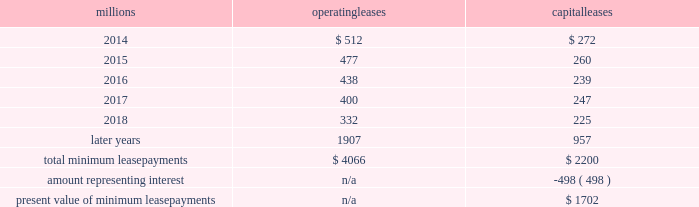On december 19 , 2011 , we redeemed the remaining $ 175 million of our 6.5% ( 6.5 % ) notes due april 15 , 2012 , and all $ 300 million of our outstanding 6.125% ( 6.125 % ) notes due january 15 , 2012 .
The redemptions resulted in an early extinguishment charge of $ 5 million in the fourth quarter of 2011 .
Receivables securitization facility 2013 as of december 31 , 2013 and 2012 , we recorded $ 0 and $ 100 million , respectively , as secured debt under our receivables securitization facility .
( see further discussion of our receivables securitization facility in note 10 ) .
15 .
Variable interest entities we have entered into various lease transactions in which the structure of the leases contain variable interest entities ( vies ) .
These vies were created solely for the purpose of doing lease transactions ( principally involving railroad equipment and facilities , including our headquarters building ) and have no other activities , assets or liabilities outside of the lease transactions .
Within these lease arrangements , we have the right to purchase some or all of the assets at fixed prices .
Depending on market conditions , fixed-price purchase options available in the leases could potentially provide benefits to us ; however , these benefits are not expected to be significant .
We maintain and operate the assets based on contractual obligations within the lease arrangements , which set specific guidelines consistent within the railroad industry .
As such , we have no control over activities that could materially impact the fair value of the leased assets .
We do not hold the power to direct the activities of the vies and , therefore , do not control the ongoing activities that have a significant impact on the economic performance of the vies .
Additionally , we do not have the obligation to absorb losses of the vies or the right to receive benefits of the vies that could potentially be significant to the we are not considered to be the primary beneficiary and do not consolidate these vies because our actions and decisions do not have the most significant effect on the vie 2019s performance and our fixed-price purchase price options are not considered to be potentially significant to the vies .
The future minimum lease payments associated with the vie leases totaled $ 3.3 billion as of december 31 , 2013 .
16 .
Leases we lease certain locomotives , freight cars , and other property .
The consolidated statements of financial position as of december 31 , 2013 and 2012 included $ 2486 million , net of $ 1092 million of accumulated depreciation , and $ 2467 million , net of $ 966 million of accumulated depreciation , respectively , for properties held under capital leases .
A charge to income resulting from the depreciation for assets held under capital leases is included within depreciation expense in our consolidated statements of income .
Future minimum lease payments for operating and capital leases with initial or remaining non-cancelable lease terms in excess of one year as of december 31 , 2013 , were as follows : millions operating leases capital leases .
Approximately 94% ( 94 % ) of capital lease payments relate to locomotives .
Rent expense for operating leases with terms exceeding one month was $ 618 million in 2013 , $ 631 million in 2012 , and $ 637 million in 2011 .
When cash rental payments are not made on a straight-line basis , we recognize variable rental expense on a straight-line basis over the lease term .
Contingent rentals and sub-rentals are not significant. .
What was the percentage change in rent expense for operating leases with terms exceeding one month from 2012 to 2013? 
Computations: ((618 - 631) / 631)
Answer: -0.0206. 